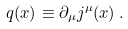Convert formula to latex. <formula><loc_0><loc_0><loc_500><loc_500>q ( x ) \equiv \partial _ { \mu } j ^ { \mu } ( x ) \, .</formula> 